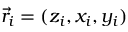Convert formula to latex. <formula><loc_0><loc_0><loc_500><loc_500>\vec { r } _ { i } = ( z _ { i } , x _ { i } , y _ { i } )</formula> 